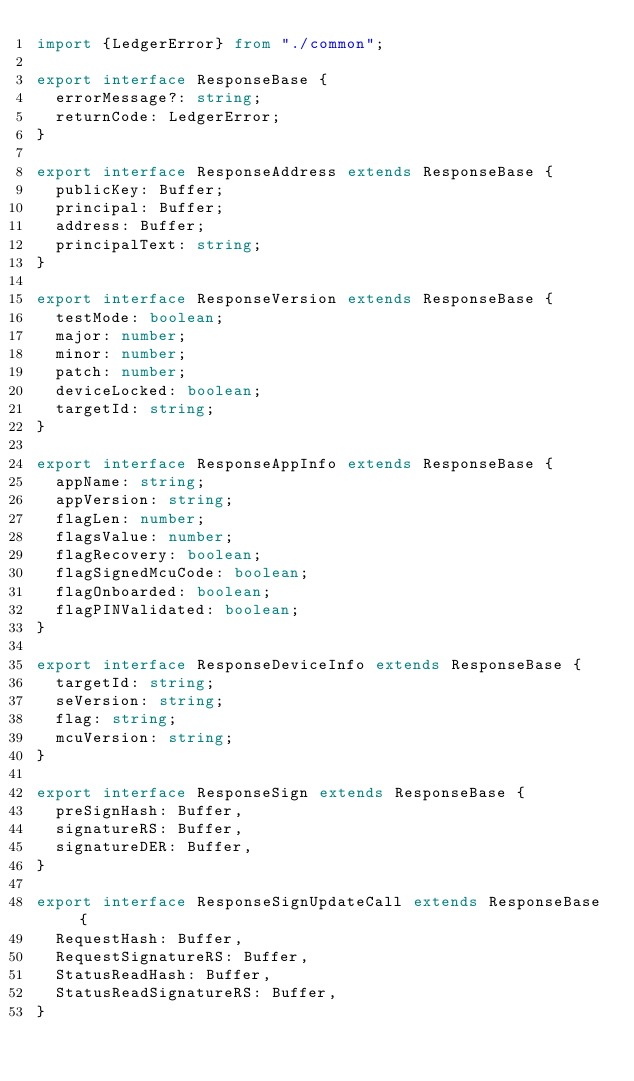<code> <loc_0><loc_0><loc_500><loc_500><_TypeScript_>import {LedgerError} from "./common";

export interface ResponseBase {
  errorMessage?: string;
  returnCode: LedgerError;
}

export interface ResponseAddress extends ResponseBase {
  publicKey: Buffer;
  principal: Buffer;
  address: Buffer;
  principalText: string;
}

export interface ResponseVersion extends ResponseBase {
  testMode: boolean;
  major: number;
  minor: number;
  patch: number;
  deviceLocked: boolean;
  targetId: string;
}

export interface ResponseAppInfo extends ResponseBase {
  appName: string;
  appVersion: string;
  flagLen: number;
  flagsValue: number;
  flagRecovery: boolean;
  flagSignedMcuCode: boolean;
  flagOnboarded: boolean;
  flagPINValidated: boolean;
}

export interface ResponseDeviceInfo extends ResponseBase {
  targetId: string;
  seVersion: string;
  flag: string;
  mcuVersion: string;
}

export interface ResponseSign extends ResponseBase {
  preSignHash: Buffer,
  signatureRS: Buffer,
  signatureDER: Buffer,
}

export interface ResponseSignUpdateCall extends ResponseBase {
  RequestHash: Buffer,
  RequestSignatureRS: Buffer,
  StatusReadHash: Buffer,
  StatusReadSignatureRS: Buffer,
}
</code> 